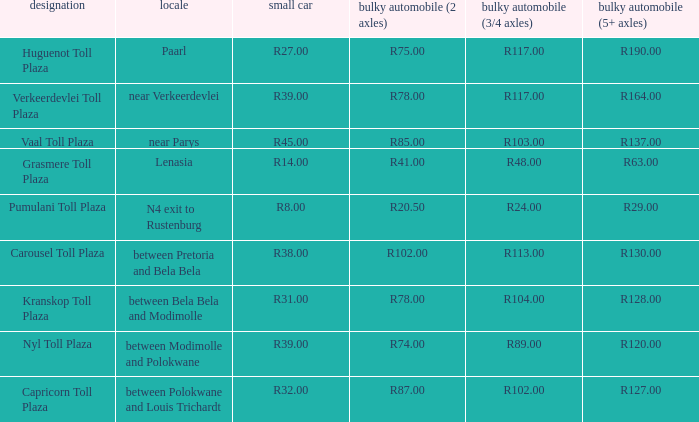What is the toll for light vehicles at the plaza between bela bela and modimolle? R31.00. 